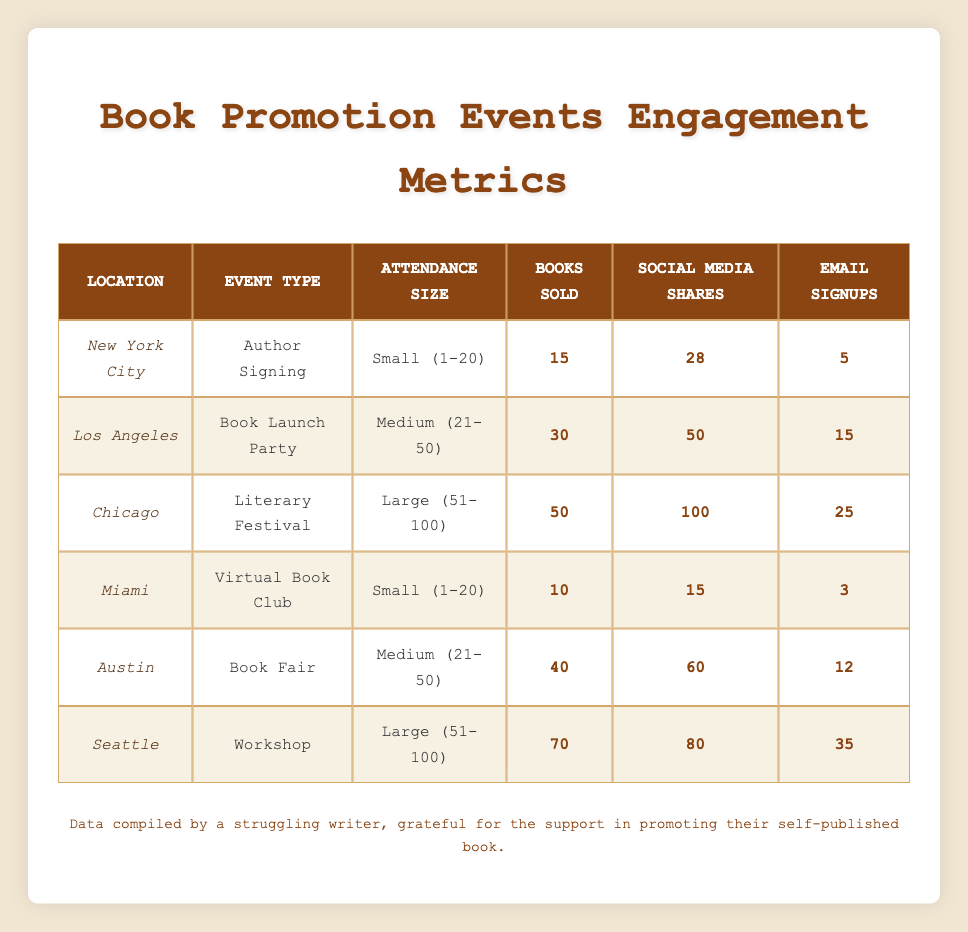What are the total books sold across all events? To find the total books sold, you need to add the number of books sold from each event. The values are: 15 (NYC) + 30 (LA) + 50 (Chicago) + 10 (Miami) + 40 (Austin) + 70 (Seattle). Summing these: 15 + 30 + 50 + 10 + 40 + 70 = 215.
Answer: 215 Which event had the highest number of social media shares? By reviewing the table, the highest number of social media shares is found in Chicago at the Literary Festival, where 100 shares were recorded.
Answer: 100 Did Miami have more email signups than New York City? Reviewing the email signups, Miami had 3 while New York City had 5. Since 3 is less than 5, the answer is no.
Answer: No What is the average number of books sold at large events? The large events are in Chicago and Seattle, with books sold values of 50 and 70 respectively. To find the average, sum these two values to get 120, and divide by the number of events (2): 120 / 2 = 60.
Answer: 60 Which location sold the least amount of books? Looking at the books sold per location, Miami sold 10, which is the lowest compared to all other locations listed (15, 30, 50, 40, and 70 books).
Answer: Miami How many email signups did events in medium attendance sizes generate in total? The medium attendance sizes are from Los Angeles (15 signups) and Austin (12 signups). Adding them gives: 15 + 12 = 27 email signups from medium events.
Answer: 27 